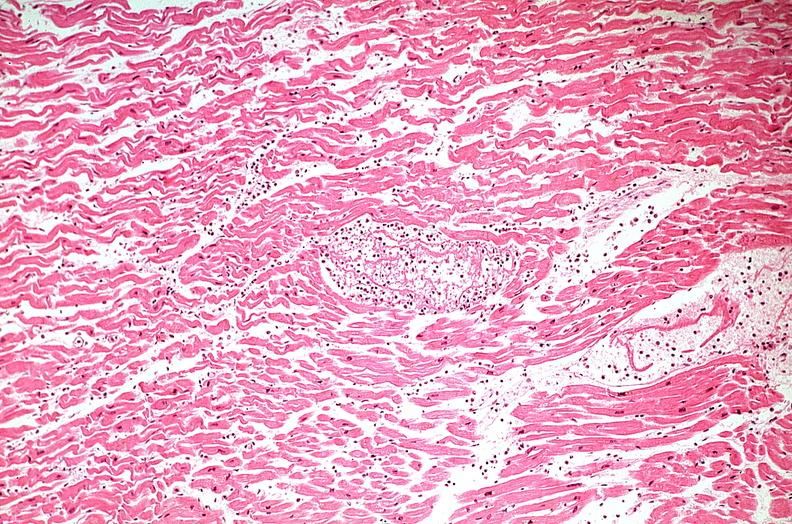does sacrococcygeal teratoma show heart, myocardial infarction, wavey fiber change, necrtosis, hemorrhage, and dissection?
Answer the question using a single word or phrase. No 